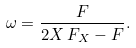Convert formula to latex. <formula><loc_0><loc_0><loc_500><loc_500>\omega = \frac { F } { 2 X \, F _ { X } - F } .</formula> 